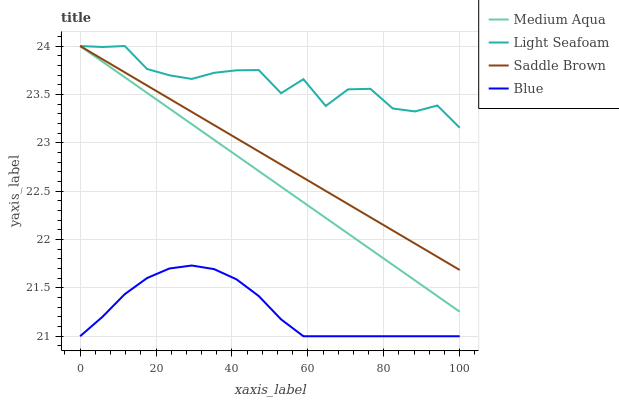Does Blue have the minimum area under the curve?
Answer yes or no. Yes. Does Light Seafoam have the maximum area under the curve?
Answer yes or no. Yes. Does Medium Aqua have the minimum area under the curve?
Answer yes or no. No. Does Medium Aqua have the maximum area under the curve?
Answer yes or no. No. Is Saddle Brown the smoothest?
Answer yes or no. Yes. Is Light Seafoam the roughest?
Answer yes or no. Yes. Is Medium Aqua the smoothest?
Answer yes or no. No. Is Medium Aqua the roughest?
Answer yes or no. No. Does Medium Aqua have the lowest value?
Answer yes or no. No. Does Saddle Brown have the highest value?
Answer yes or no. Yes. Is Blue less than Light Seafoam?
Answer yes or no. Yes. Is Medium Aqua greater than Blue?
Answer yes or no. Yes. Does Light Seafoam intersect Saddle Brown?
Answer yes or no. Yes. Is Light Seafoam less than Saddle Brown?
Answer yes or no. No. Is Light Seafoam greater than Saddle Brown?
Answer yes or no. No. Does Blue intersect Light Seafoam?
Answer yes or no. No. 